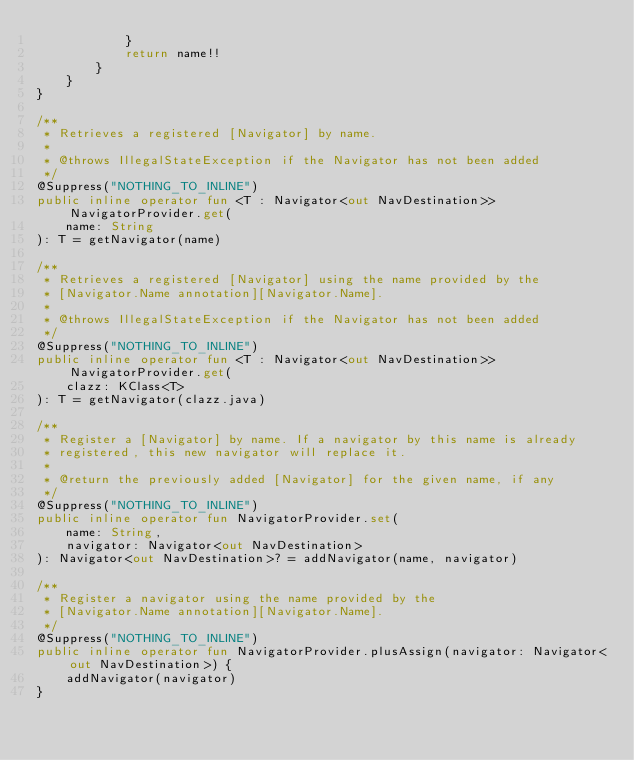Convert code to text. <code><loc_0><loc_0><loc_500><loc_500><_Kotlin_>            }
            return name!!
        }
    }
}

/**
 * Retrieves a registered [Navigator] by name.
 *
 * @throws IllegalStateException if the Navigator has not been added
 */
@Suppress("NOTHING_TO_INLINE")
public inline operator fun <T : Navigator<out NavDestination>> NavigatorProvider.get(
    name: String
): T = getNavigator(name)

/**
 * Retrieves a registered [Navigator] using the name provided by the
 * [Navigator.Name annotation][Navigator.Name].
 *
 * @throws IllegalStateException if the Navigator has not been added
 */
@Suppress("NOTHING_TO_INLINE")
public inline operator fun <T : Navigator<out NavDestination>> NavigatorProvider.get(
    clazz: KClass<T>
): T = getNavigator(clazz.java)

/**
 * Register a [Navigator] by name. If a navigator by this name is already
 * registered, this new navigator will replace it.
 *
 * @return the previously added [Navigator] for the given name, if any
 */
@Suppress("NOTHING_TO_INLINE")
public inline operator fun NavigatorProvider.set(
    name: String,
    navigator: Navigator<out NavDestination>
): Navigator<out NavDestination>? = addNavigator(name, navigator)

/**
 * Register a navigator using the name provided by the
 * [Navigator.Name annotation][Navigator.Name].
 */
@Suppress("NOTHING_TO_INLINE")
public inline operator fun NavigatorProvider.plusAssign(navigator: Navigator<out NavDestination>) {
    addNavigator(navigator)
}
</code> 